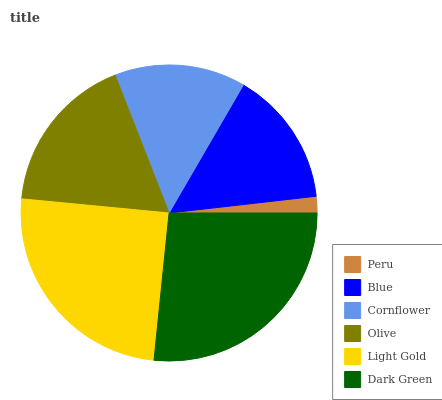Is Peru the minimum?
Answer yes or no. Yes. Is Dark Green the maximum?
Answer yes or no. Yes. Is Blue the minimum?
Answer yes or no. No. Is Blue the maximum?
Answer yes or no. No. Is Blue greater than Peru?
Answer yes or no. Yes. Is Peru less than Blue?
Answer yes or no. Yes. Is Peru greater than Blue?
Answer yes or no. No. Is Blue less than Peru?
Answer yes or no. No. Is Olive the high median?
Answer yes or no. Yes. Is Blue the low median?
Answer yes or no. Yes. Is Dark Green the high median?
Answer yes or no. No. Is Light Gold the low median?
Answer yes or no. No. 